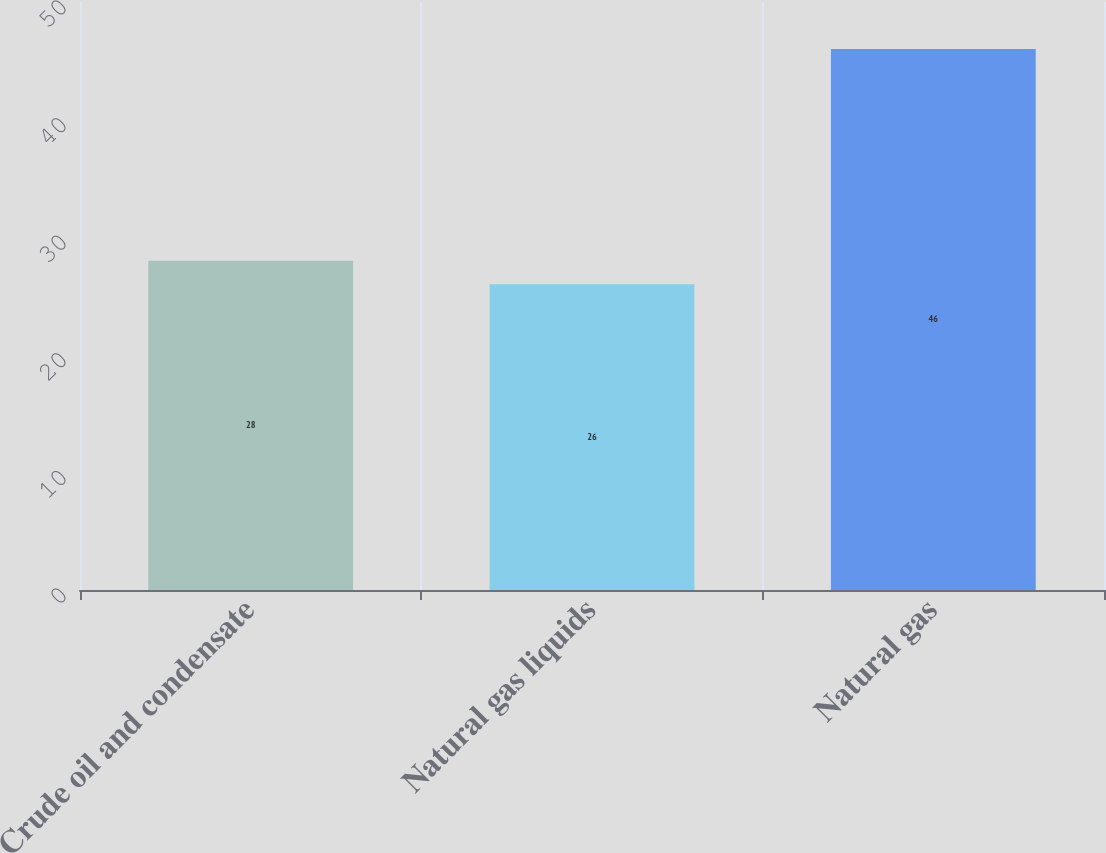<chart> <loc_0><loc_0><loc_500><loc_500><bar_chart><fcel>Crude oil and condensate<fcel>Natural gas liquids<fcel>Natural gas<nl><fcel>28<fcel>26<fcel>46<nl></chart> 